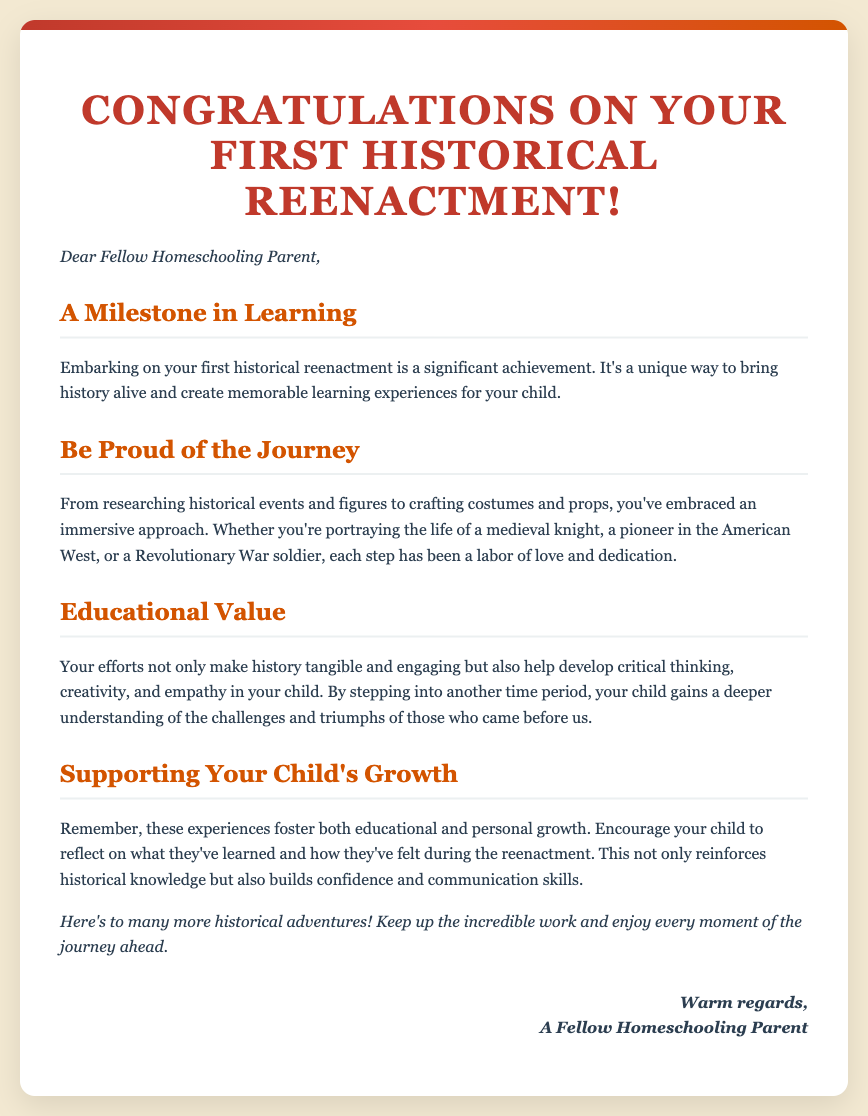What is the title of the card? The title is the main heading displayed prominently at the top of the card.
Answer: Congratulations on Your First Historical Reenactment! Who is the card addressed to? The introduction directly addresses the intended recipient of the card, indicating a personal connection.
Answer: Fellow Homeschooling Parent What is mentioned as a significant achievement? The document emphasizes the importance of the first reenactment as a specific milestone in the recipient's journey.
Answer: First historical reenactment What emotional response does the card encourage? The text encourages pride in the efforts made throughout the reenactment process, reflecting a positive sentiment.
Answer: Be proud What is a key educational value highlighted in the card? The document discusses what the reenactment helps develop in the child, pointing to an aspect of personal growth.
Answer: Critical thinking What type of historical roles are mentioned in the card? The document lists various historical figures or roles that parents might portray during reenactments.
Answer: Medieval knight, pioneer, Revolutionary War soldier What does the card suggest about the personal growth of a child? The card indicates a dual focus on educational and personal development stemming from the experience.
Answer: Fosters growth How does the card conclude? The closing message summarizes the overall sentiment of encouragement for future adventures.
Answer: Here's to many more historical adventures! 